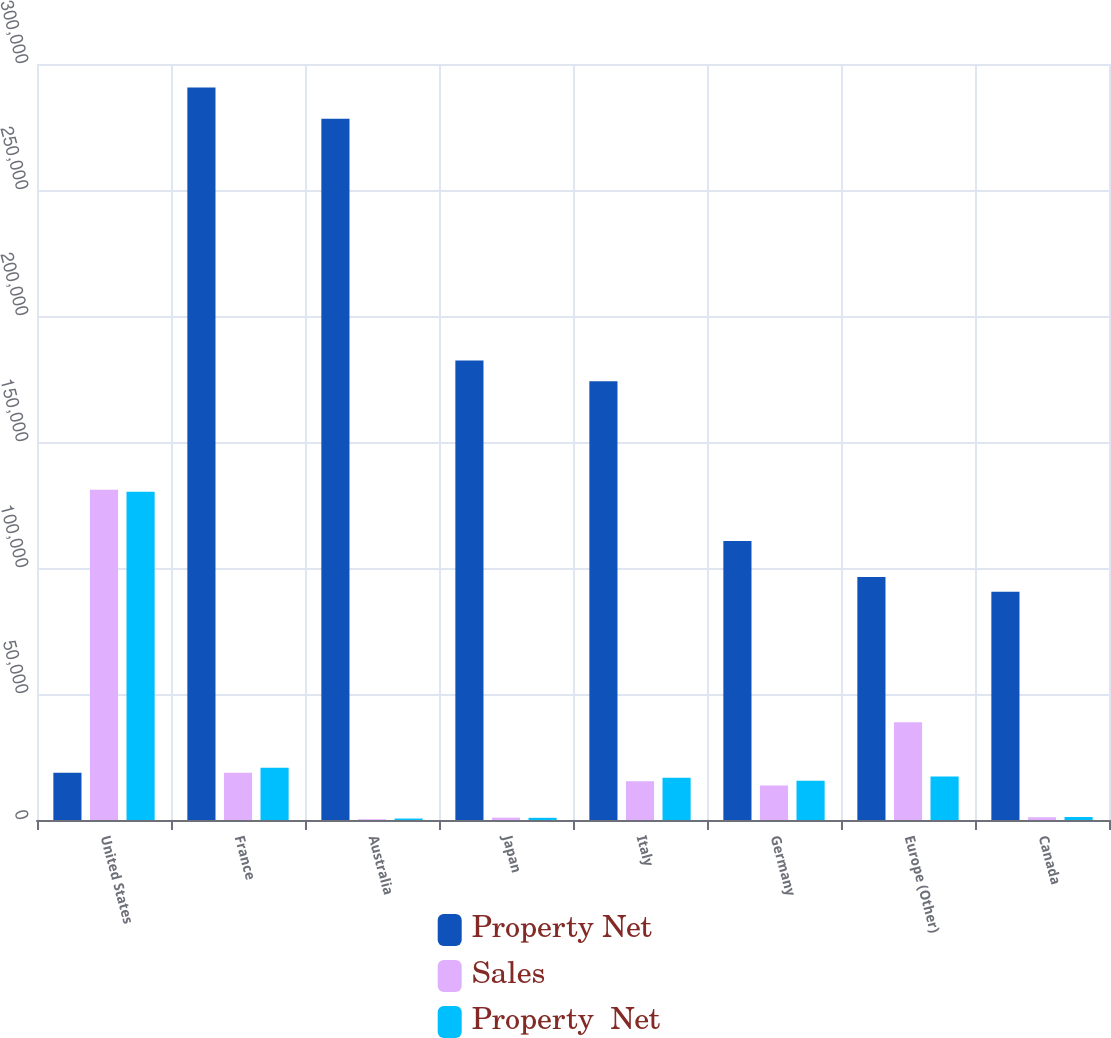Convert chart to OTSL. <chart><loc_0><loc_0><loc_500><loc_500><stacked_bar_chart><ecel><fcel>United States<fcel>France<fcel>Australia<fcel>Japan<fcel>Italy<fcel>Germany<fcel>Europe (Other)<fcel>Canada<nl><fcel>Property Net<fcel>18776<fcel>290698<fcel>278298<fcel>182307<fcel>174095<fcel>110748<fcel>96381<fcel>90585<nl><fcel>Sales<fcel>131081<fcel>18776<fcel>320<fcel>942<fcel>15405<fcel>13649<fcel>38825<fcel>1093<nl><fcel>Property  Net<fcel>130235<fcel>20777<fcel>579<fcel>867<fcel>16785<fcel>15573<fcel>17242<fcel>1196<nl></chart> 